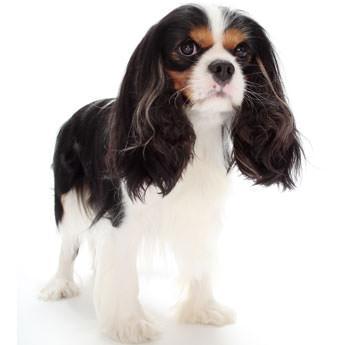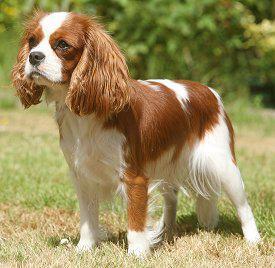The first image is the image on the left, the second image is the image on the right. Examine the images to the left and right. Is the description "There are a total of three cocker spaniels" accurate? Answer yes or no. No. The first image is the image on the left, the second image is the image on the right. Assess this claim about the two images: "One image includes twice as many dogs as the other image.". Correct or not? Answer yes or no. No. 